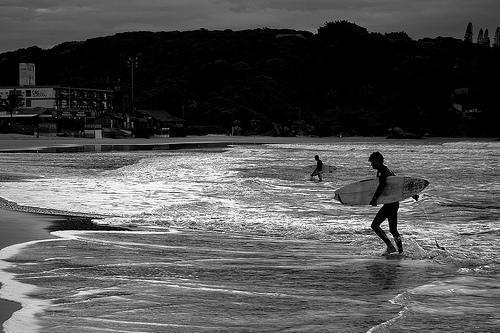How many people are walking in the water?
Give a very brief answer. 2. 